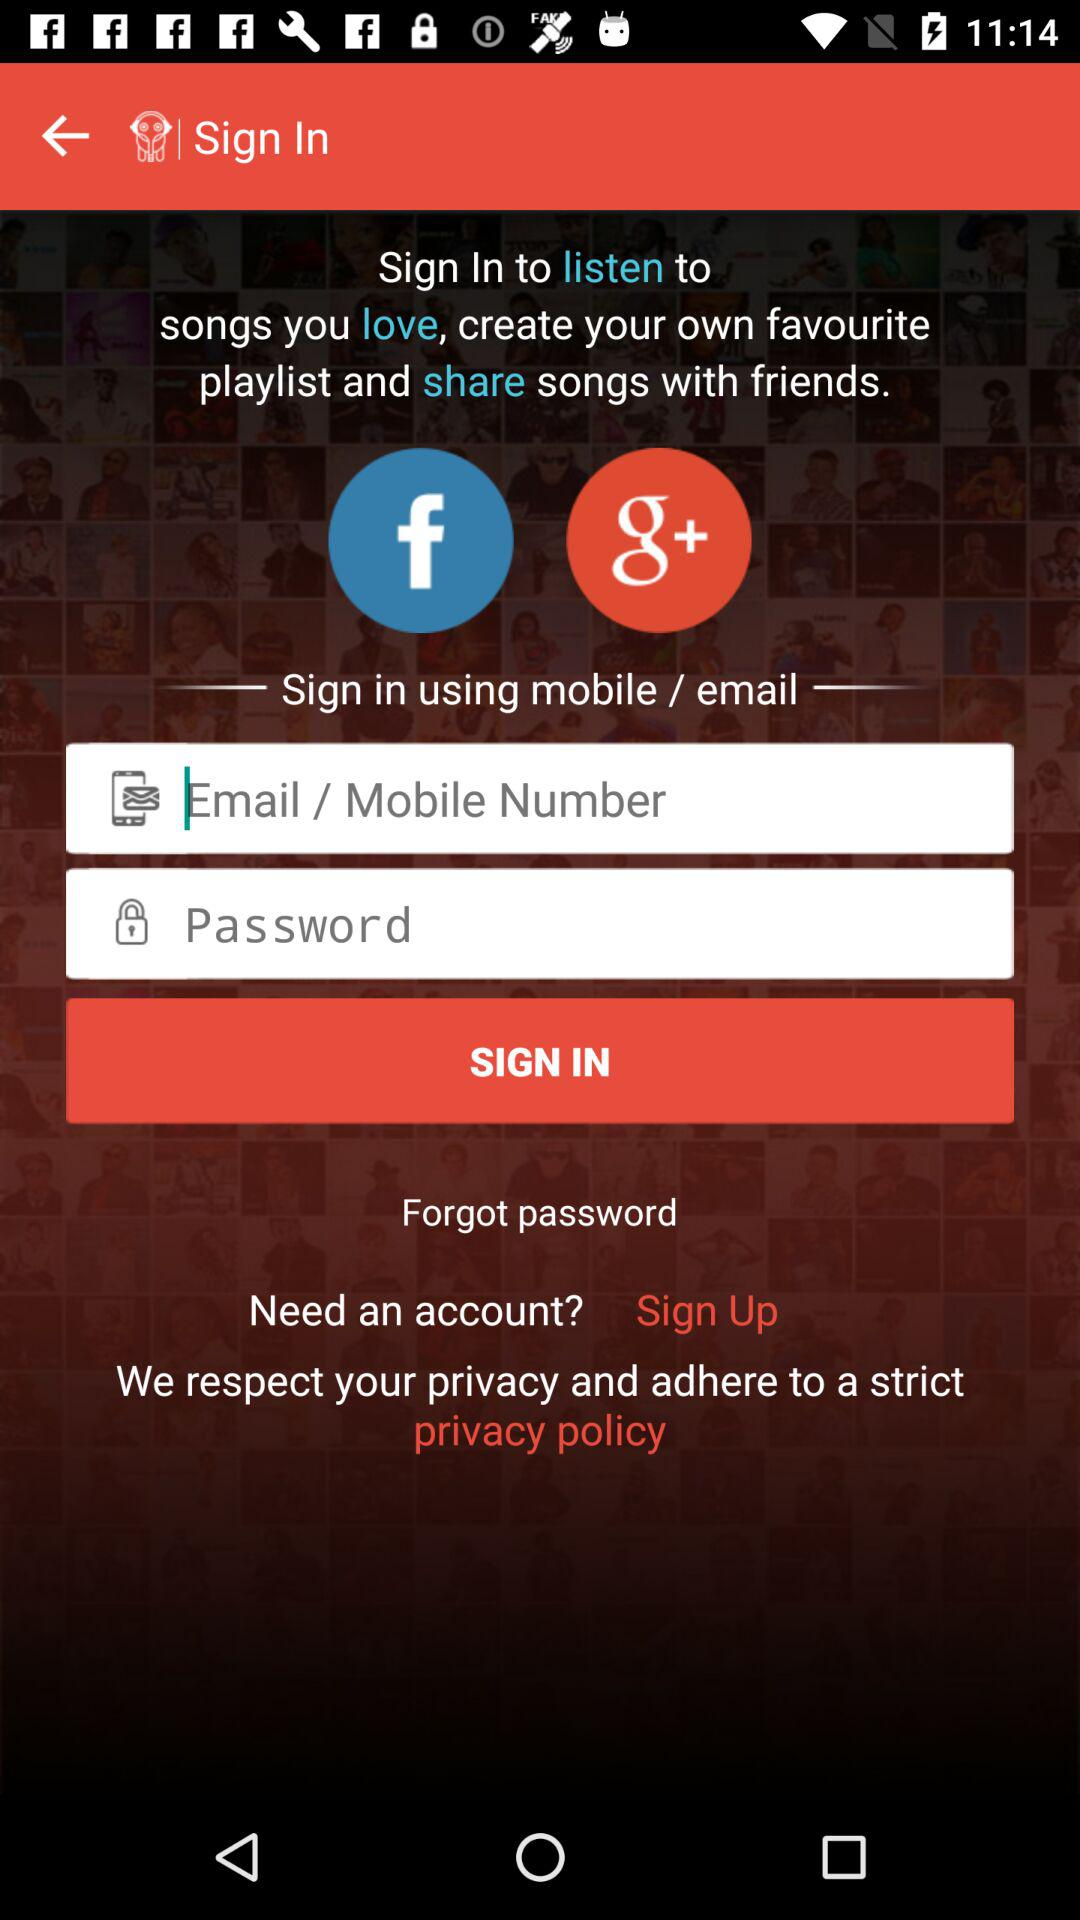Which applications are used to sign in? The applications are "Facebook" and "Google+". 